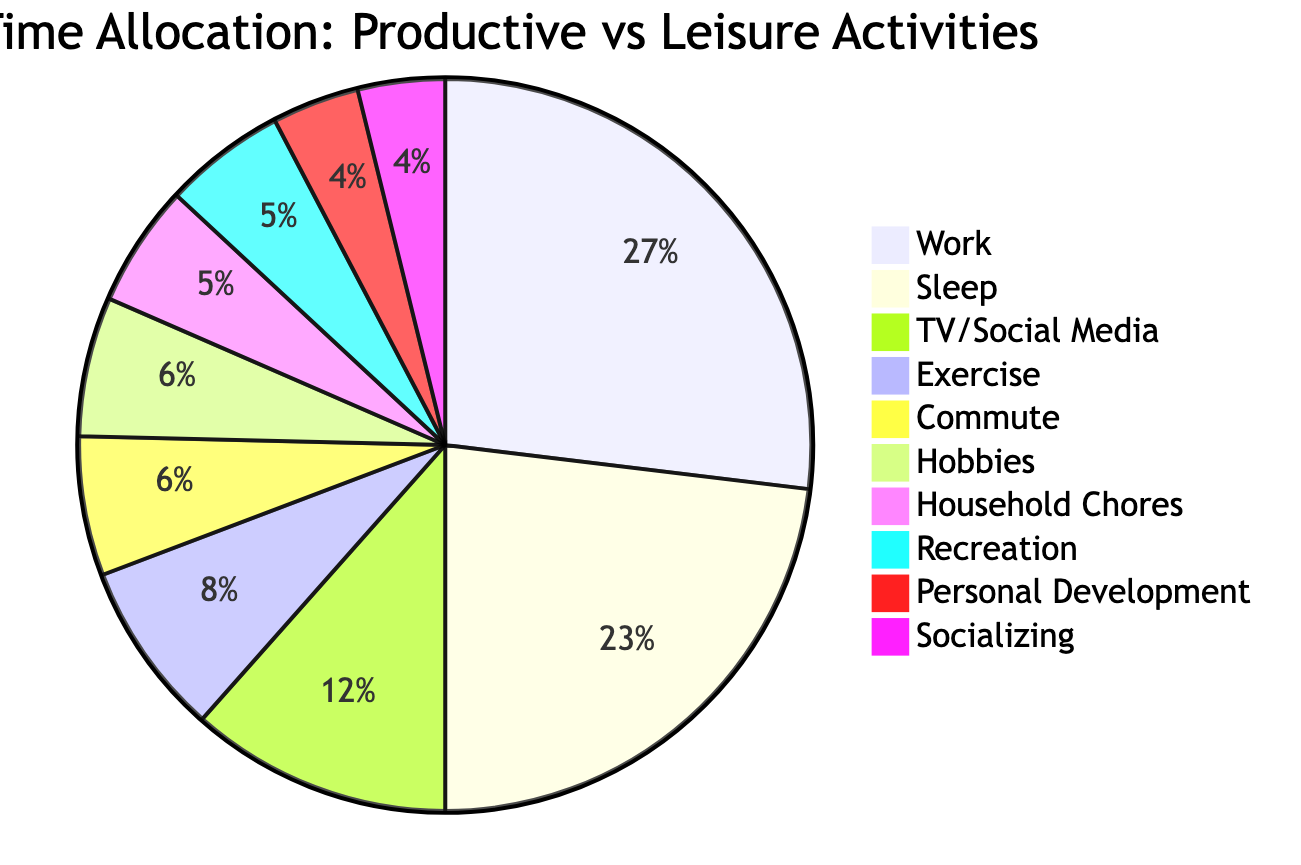What is the percentage of time allocated to sleep? The diagram indicates that Sleep is a labeled section with a value of 30. The allocation for Sleep directly states that it occupies 30% of the day.
Answer: 30% How much time is spent on House chores compared to Hobbies? The diagram shows Households Chores having a value of 7 and Hobbies having a value of 8. Comparing these two values, Hobbies takes up 1% more time than Household Chores.
Answer: Hobbies by 1% What is the total percentage of time spent on productive activities? To find the total percentage of productive activities, add the values attributed to Work, Exercise, Household Chores, and Personal Development: 35 (Work) + 10 (Exercise) + 7 (Household Chores) + 5 (Personal Development) = 57%.
Answer: 57% Which activity has the highest time allocation? By examining the pie chart, the segment labeled Work occupies the largest section with a value of 35, indicating that it has the highest time allocation compared to other activities.
Answer: Work What percentage of time is allocated to leisure activities? Leisure activities include TV/Social Media, Hobbies, Socializing, and Recreation: 15 (TV/Social Media) + 8 (Hobbies) + 5 (Socializing) + 7 (Recreation) = 35%. Hence, 35% of the time is allocated for leisure activities.
Answer: 35% How much time is spent commuting? The diagram labels Commute with a value of 8. Therefore, the time allocated to commuting is specifically noted as 8% of the day.
Answer: 8% 